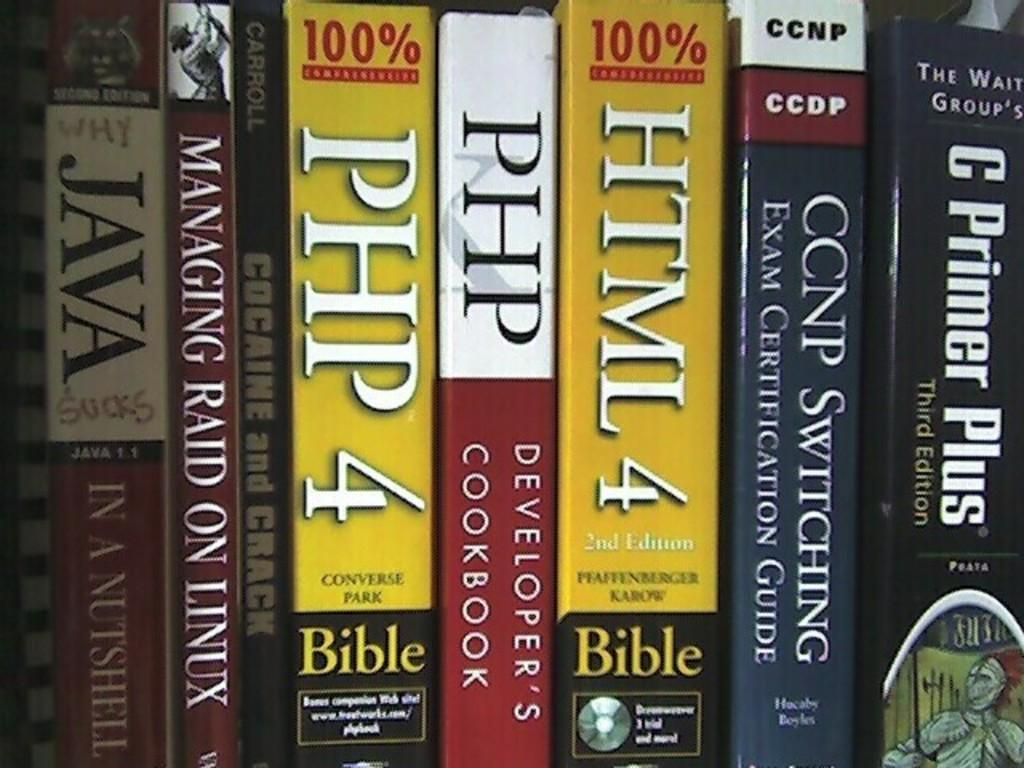<image>
Present a compact description of the photo's key features. A row of books on a shelf including Developer's Cookbook. 